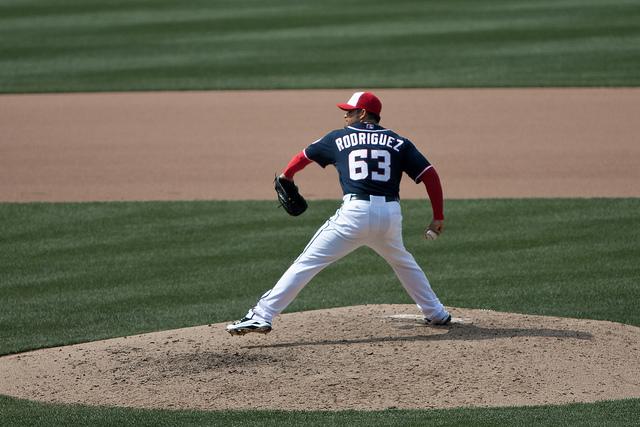Is the player in blue the pitcher?
Give a very brief answer. Yes. What number is the uniform?
Short answer required. 63. Which foot is touching the base?
Concise answer only. Right. What is he doing?
Be succinct. Pitching. 